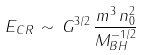Convert formula to latex. <formula><loc_0><loc_0><loc_500><loc_500>E _ { C R } \, \sim \, G ^ { 3 / 2 } \, \frac { m ^ { 3 } \, n _ { 0 } ^ { 2 } } { M _ { B H } ^ { - 1 / 2 } }</formula> 